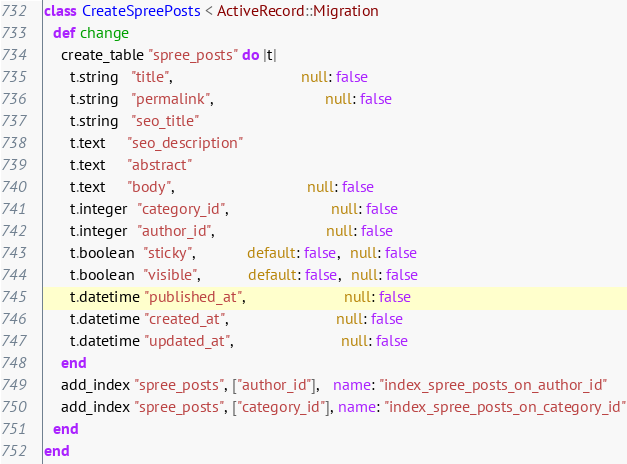Convert code to text. <code><loc_0><loc_0><loc_500><loc_500><_Ruby_>class CreateSpreePosts < ActiveRecord::Migration
  def change
    create_table "spree_posts" do |t|
      t.string   "title",                              null: false
      t.string   "permalink",                          null: false
      t.string   "seo_title"
      t.text     "seo_description"
      t.text     "abstract"
      t.text     "body",                               null: false
      t.integer  "category_id",                        null: false
      t.integer  "author_id",                          null: false
      t.boolean  "sticky",            default: false,  null: false
      t.boolean  "visible",           default: false,  null: false
      t.datetime "published_at",                       null: false
      t.datetime "created_at",                         null: false
      t.datetime "updated_at",                         null: false
    end
    add_index "spree_posts", ["author_id"],   name: "index_spree_posts_on_author_id"
    add_index "spree_posts", ["category_id"], name: "index_spree_posts_on_category_id"
  end
end
</code> 